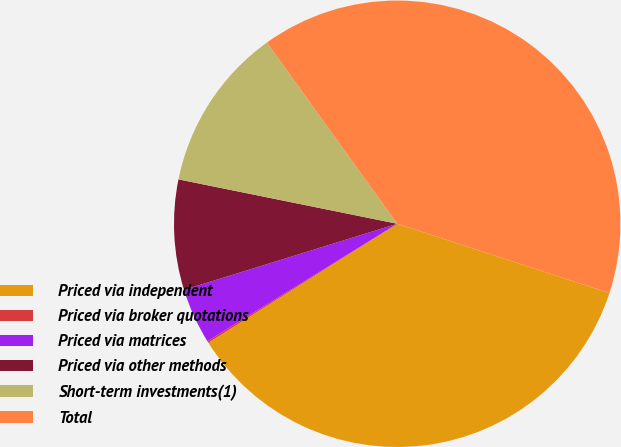Convert chart to OTSL. <chart><loc_0><loc_0><loc_500><loc_500><pie_chart><fcel>Priced via independent<fcel>Priced via broker quotations<fcel>Priced via matrices<fcel>Priced via other methods<fcel>Short-term investments(1)<fcel>Total<nl><fcel>36.03%<fcel>0.12%<fcel>4.04%<fcel>7.97%<fcel>11.89%<fcel>39.95%<nl></chart> 